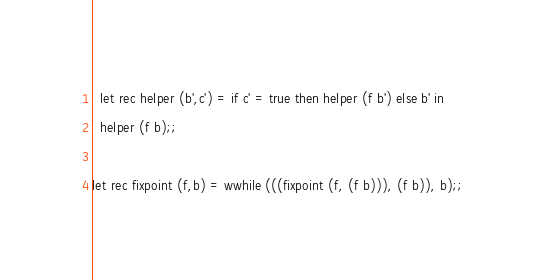<code> <loc_0><loc_0><loc_500><loc_500><_OCaml_>  let rec helper (b',c') = if c' = true then helper (f b') else b' in
  helper (f b);;

let rec fixpoint (f,b) = wwhile (((fixpoint (f, (f b))), (f b)), b);;
</code> 